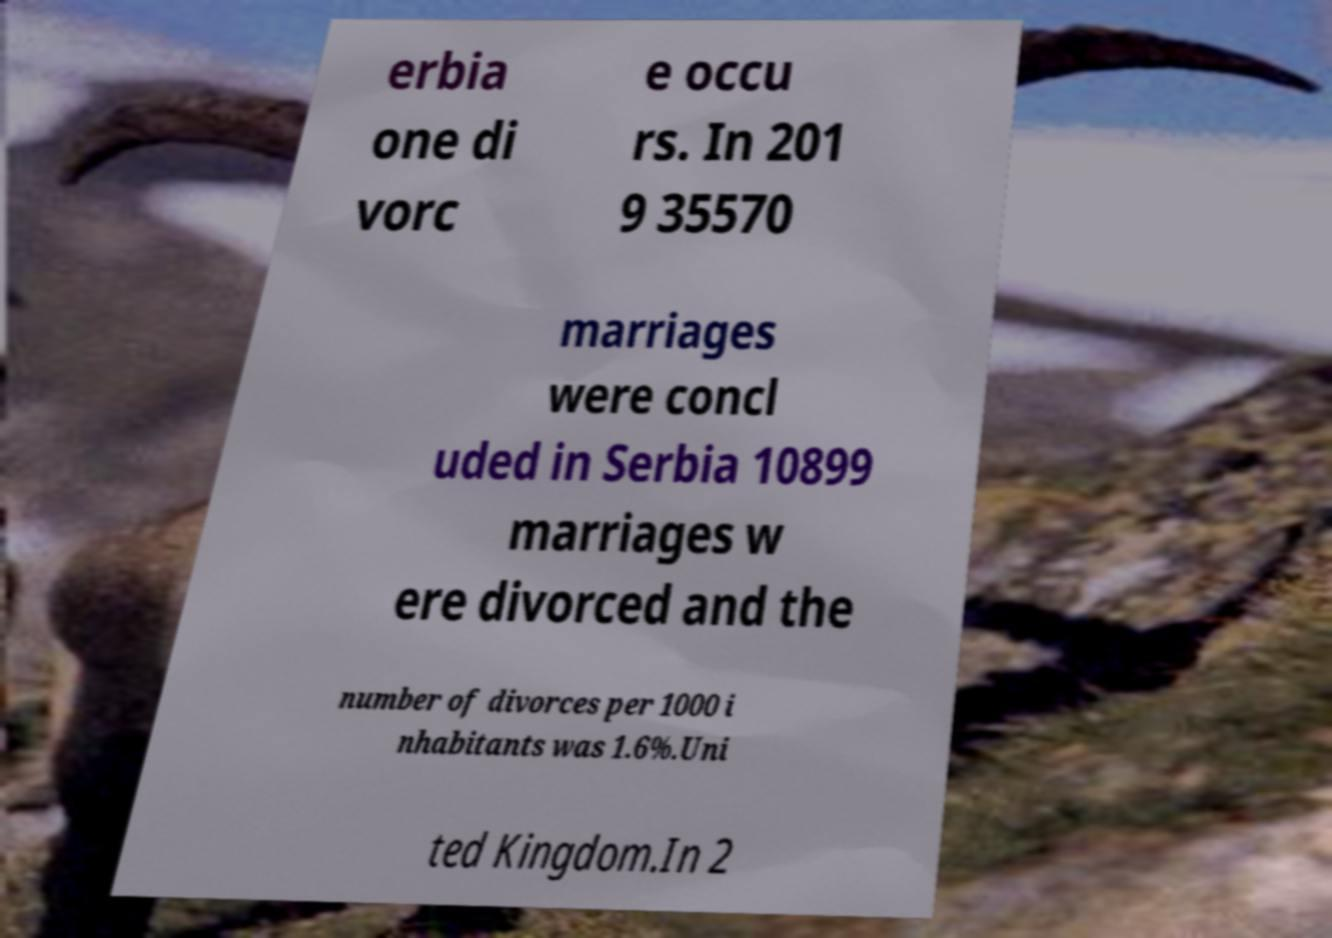There's text embedded in this image that I need extracted. Can you transcribe it verbatim? erbia one di vorc e occu rs. In 201 9 35570 marriages were concl uded in Serbia 10899 marriages w ere divorced and the number of divorces per 1000 i nhabitants was 1.6%.Uni ted Kingdom.In 2 